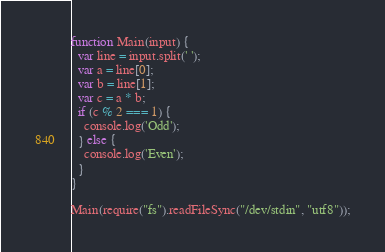Convert code to text. <code><loc_0><loc_0><loc_500><loc_500><_JavaScript_>function Main(input) {
  var line = input.split(' ');
  var a = line[0];
  var b = line[1];
  var c = a * b;
  if (c % 2 === 1) {
    console.log('Odd');
  } else {
    console.log('Even');
  }
}

Main(require("fs").readFileSync("/dev/stdin", "utf8"));
</code> 